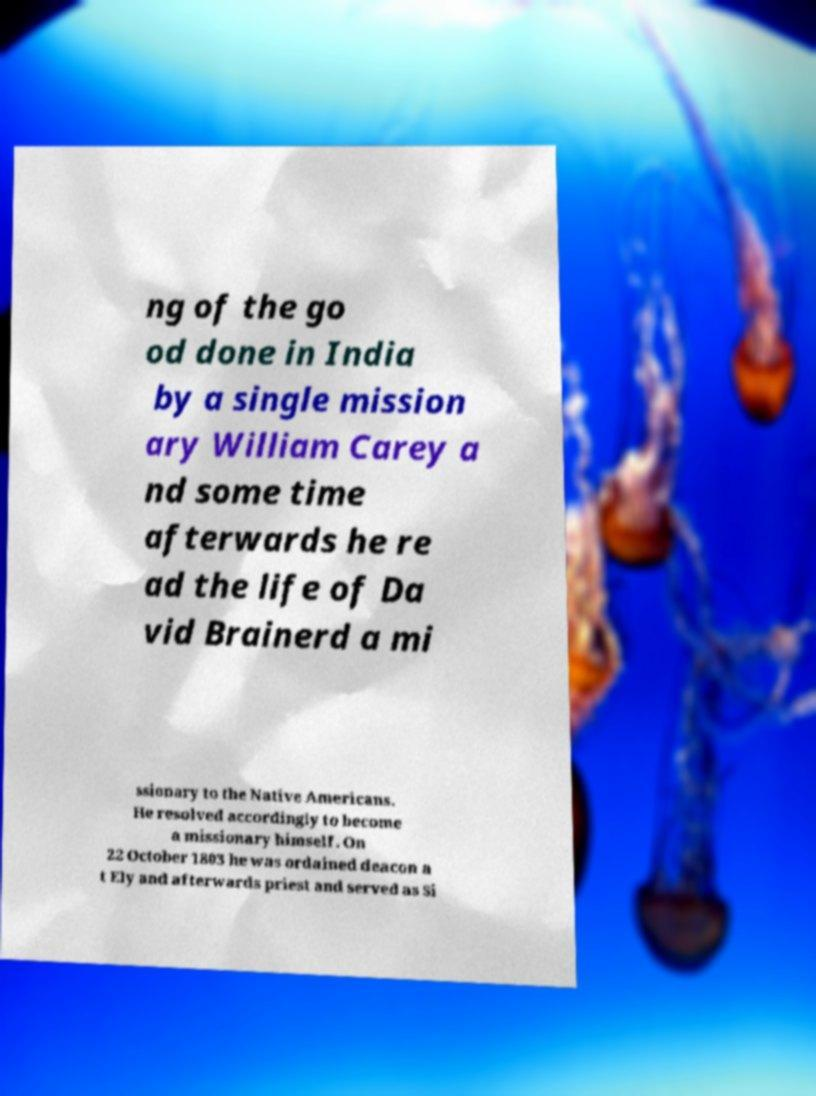Can you accurately transcribe the text from the provided image for me? ng of the go od done in India by a single mission ary William Carey a nd some time afterwards he re ad the life of Da vid Brainerd a mi ssionary to the Native Americans. He resolved accordingly to become a missionary himself. On 22 October 1803 he was ordained deacon a t Ely and afterwards priest and served as Si 